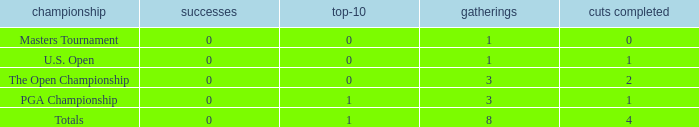For more than 3 events in the PGA Championship, what is the fewest number of wins? None. 